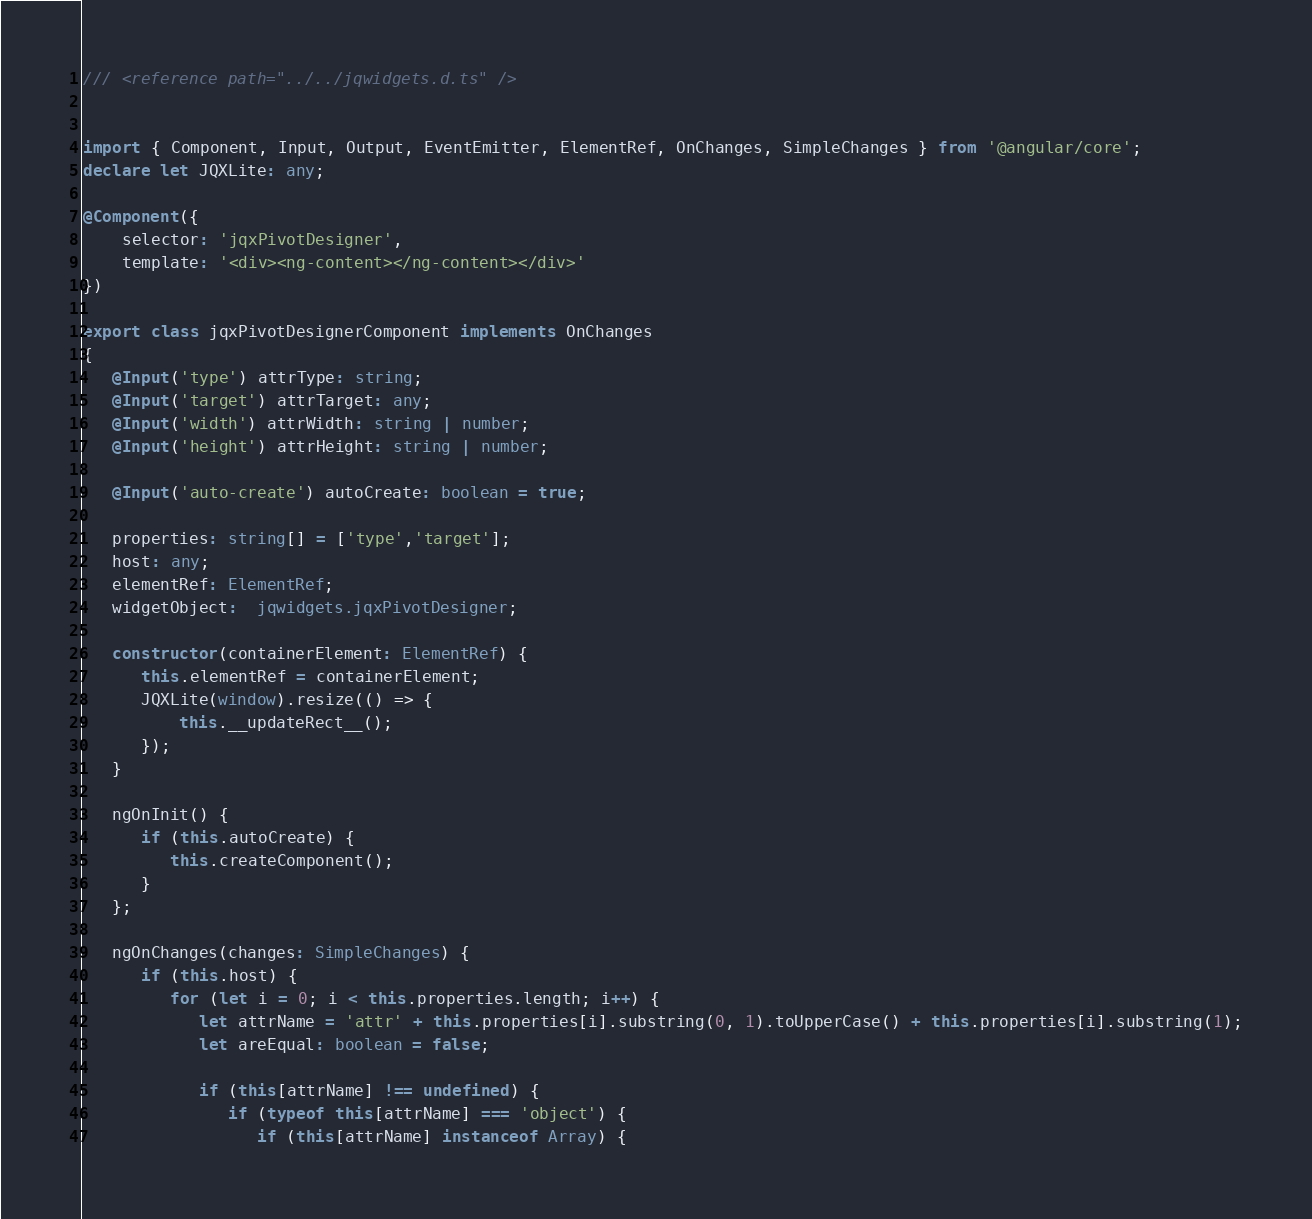Convert code to text. <code><loc_0><loc_0><loc_500><loc_500><_TypeScript_>
/// <reference path="../../jqwidgets.d.ts" />


import { Component, Input, Output, EventEmitter, ElementRef, OnChanges, SimpleChanges } from '@angular/core';
declare let JQXLite: any;

@Component({
    selector: 'jqxPivotDesigner',
    template: '<div><ng-content></ng-content></div>'
})

export class jqxPivotDesignerComponent implements OnChanges
{
   @Input('type') attrType: string;
   @Input('target') attrTarget: any;
   @Input('width') attrWidth: string | number;
   @Input('height') attrHeight: string | number;

   @Input('auto-create') autoCreate: boolean = true;

   properties: string[] = ['type','target'];
   host: any;
   elementRef: ElementRef;
   widgetObject:  jqwidgets.jqxPivotDesigner;

   constructor(containerElement: ElementRef) {
      this.elementRef = containerElement;
      JQXLite(window).resize(() => {
          this.__updateRect__();
      });
   }

   ngOnInit() {
      if (this.autoCreate) {
         this.createComponent(); 
      }
   }; 

   ngOnChanges(changes: SimpleChanges) {
      if (this.host) {
         for (let i = 0; i < this.properties.length; i++) {
            let attrName = 'attr' + this.properties[i].substring(0, 1).toUpperCase() + this.properties[i].substring(1);
            let areEqual: boolean = false;

            if (this[attrName] !== undefined) {
               if (typeof this[attrName] === 'object') {
                  if (this[attrName] instanceof Array) {</code> 